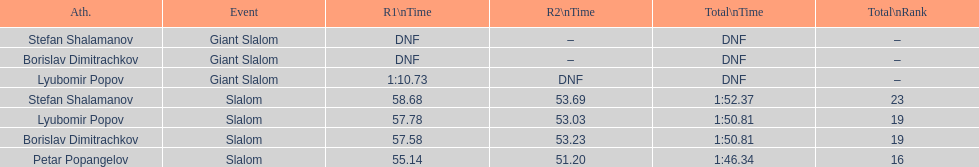Who was last in the slalom overall? Stefan Shalamanov. 